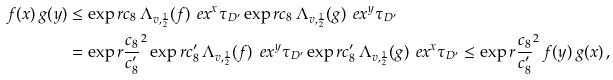Convert formula to latex. <formula><loc_0><loc_0><loc_500><loc_500>f ( x ) \, g ( y ) & \leq \exp r { c _ { 8 } \, \Lambda _ { v , \frac { 1 } { 2 } } ( f ) \, \ e x ^ { x } \tau _ { D ^ { \prime } } } \exp r { c _ { 8 } \, \Lambda _ { v , \frac { 1 } { 2 } } ( g ) \, \ e x ^ { y } \tau _ { D ^ { \prime } } } \\ & = \exp r { \frac { c _ { 8 } } { c _ { 8 } ^ { \prime } } } ^ { 2 } \exp r { c _ { 8 } ^ { \prime } \, \Lambda _ { v , \frac { 1 } { 2 } } ( f ) \, \ e x ^ { y } \tau _ { D ^ { \prime } } } \exp r { c _ { 8 } ^ { \prime } \, \Lambda _ { v , \frac { 1 } { 2 } } ( g ) \, \ e x ^ { x } \tau _ { D ^ { \prime } } } \leq \exp r { \frac { c _ { 8 } } { c _ { 8 } ^ { \prime } } } ^ { 2 } \, f ( y ) \, g ( x ) \, ,</formula> 